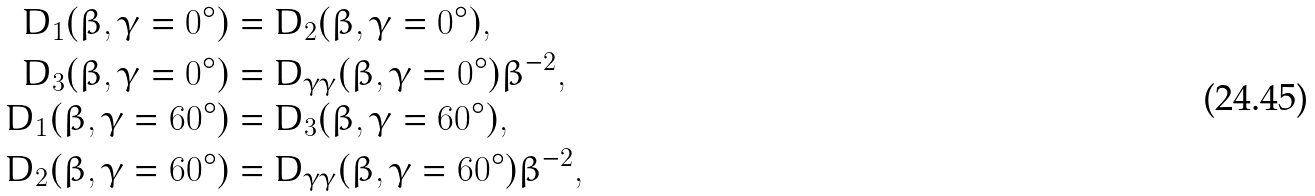<formula> <loc_0><loc_0><loc_500><loc_500>D _ { 1 } ( \beta , \gamma = 0 ^ { \circ } ) & = D _ { 2 } ( \beta , \gamma = 0 ^ { \circ } ) , \\ D _ { 3 } ( \beta , \gamma = 0 ^ { \circ } ) & = D _ { \gamma \gamma } ( \beta , \gamma = 0 ^ { \circ } ) \beta ^ { - 2 } , \\ D _ { 1 } ( \beta , \gamma = 6 0 ^ { \circ } ) & = D _ { 3 } ( \beta , \gamma = 6 0 ^ { \circ } ) , \\ D _ { 2 } ( \beta , \gamma = 6 0 ^ { \circ } ) & = D _ { \gamma \gamma } ( \beta , \gamma = 6 0 ^ { \circ } ) \beta ^ { - 2 } ,</formula> 